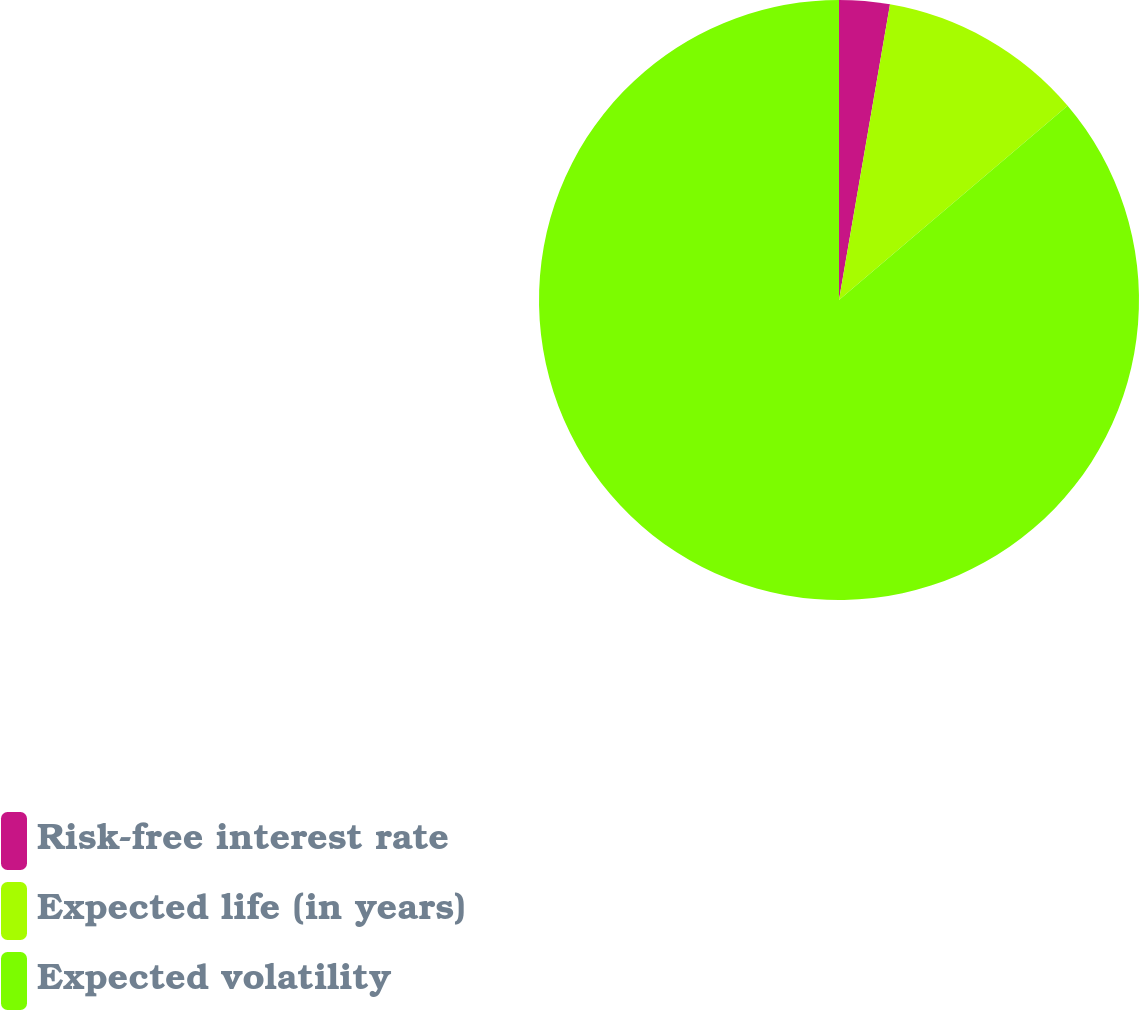Convert chart to OTSL. <chart><loc_0><loc_0><loc_500><loc_500><pie_chart><fcel>Risk-free interest rate<fcel>Expected life (in years)<fcel>Expected volatility<nl><fcel>2.72%<fcel>11.07%<fcel>86.21%<nl></chart> 